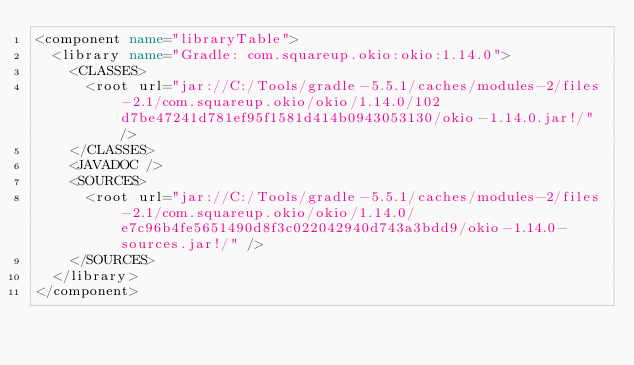<code> <loc_0><loc_0><loc_500><loc_500><_XML_><component name="libraryTable">
  <library name="Gradle: com.squareup.okio:okio:1.14.0">
    <CLASSES>
      <root url="jar://C:/Tools/gradle-5.5.1/caches/modules-2/files-2.1/com.squareup.okio/okio/1.14.0/102d7be47241d781ef95f1581d414b0943053130/okio-1.14.0.jar!/" />
    </CLASSES>
    <JAVADOC />
    <SOURCES>
      <root url="jar://C:/Tools/gradle-5.5.1/caches/modules-2/files-2.1/com.squareup.okio/okio/1.14.0/e7c96b4fe5651490d8f3c022042940d743a3bdd9/okio-1.14.0-sources.jar!/" />
    </SOURCES>
  </library>
</component></code> 